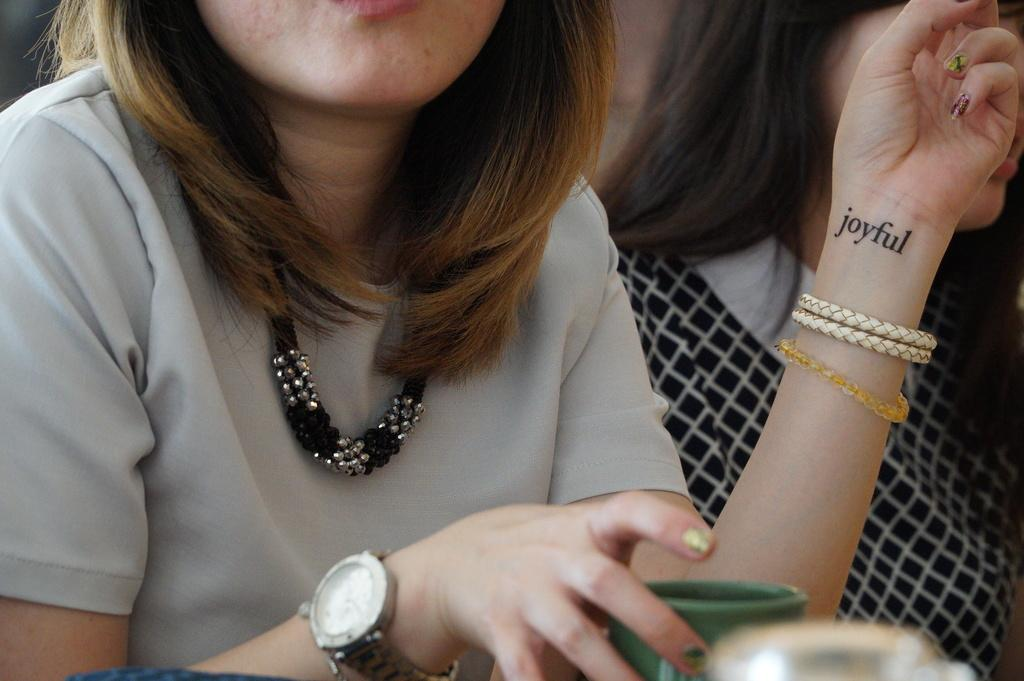Who is present in the image? There is a woman in the image. What is the woman holding in her hand? The woman is holding a cup in her hand. What accessory is the woman wearing on her wrist? The woman is wearing a watch. What is the woman wearing on her body? The woman is wearing clothes. What type of bulb can be seen in the image? There is no bulb present in the image. 